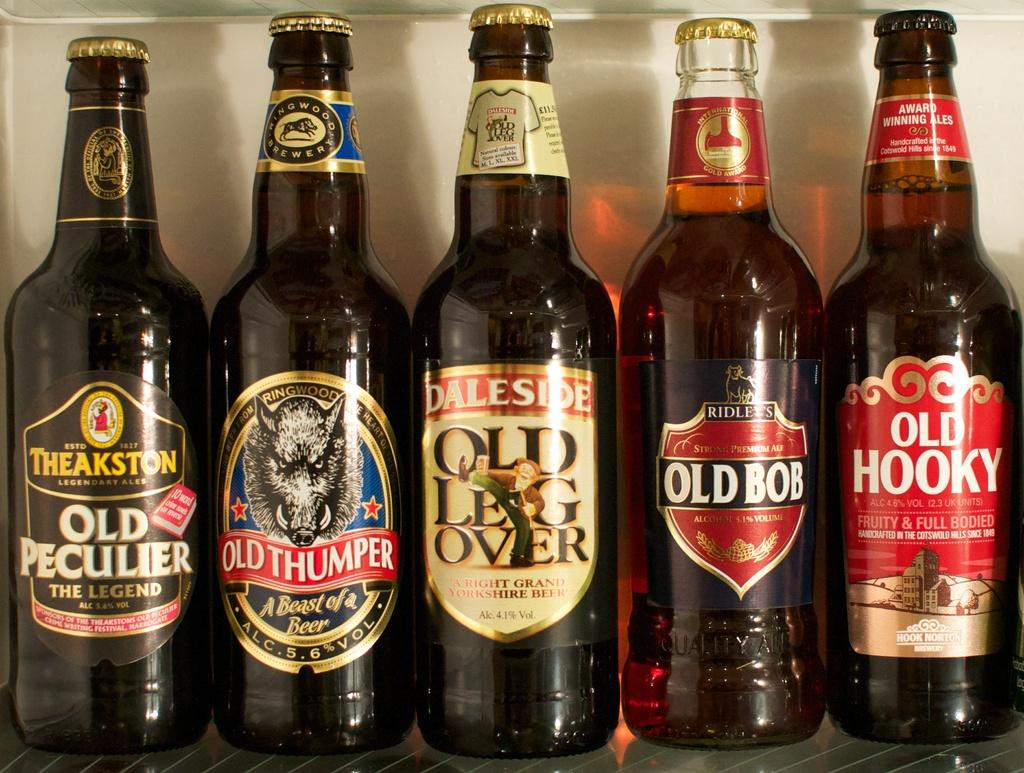Provide a one-sentence caption for the provided image. five bottles of beer that have not been opened. 